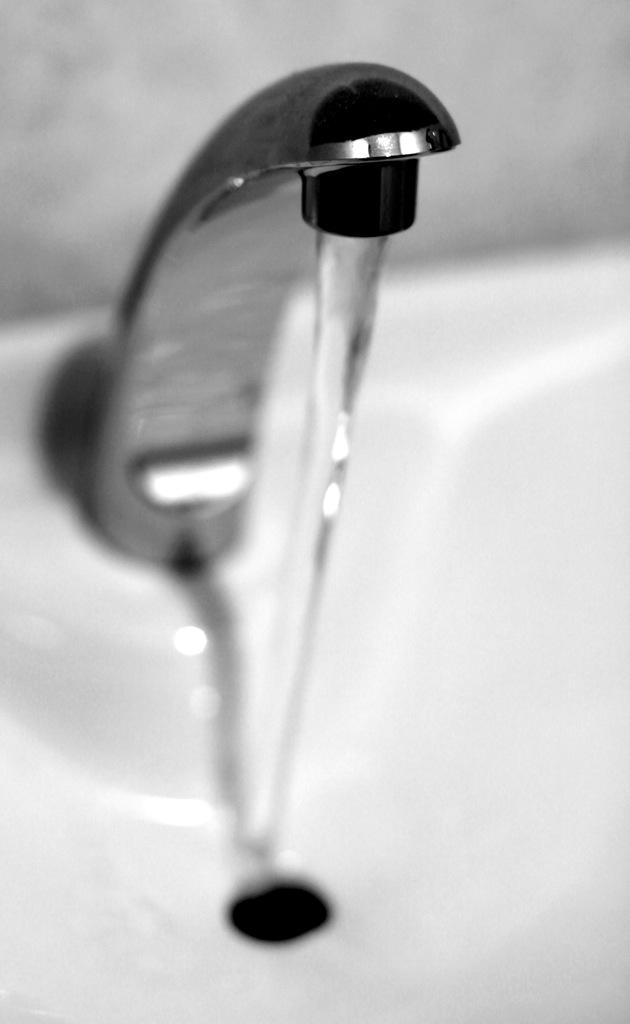What is the color scheme of the image? The image is black and white. What can be seen in the image? There is a tap in the image. What is the tap doing in the image? Water is flowing from the tap. What is the taste of the fear in the image? There is no fear present in the image, and therefore no taste can be associated with it. 